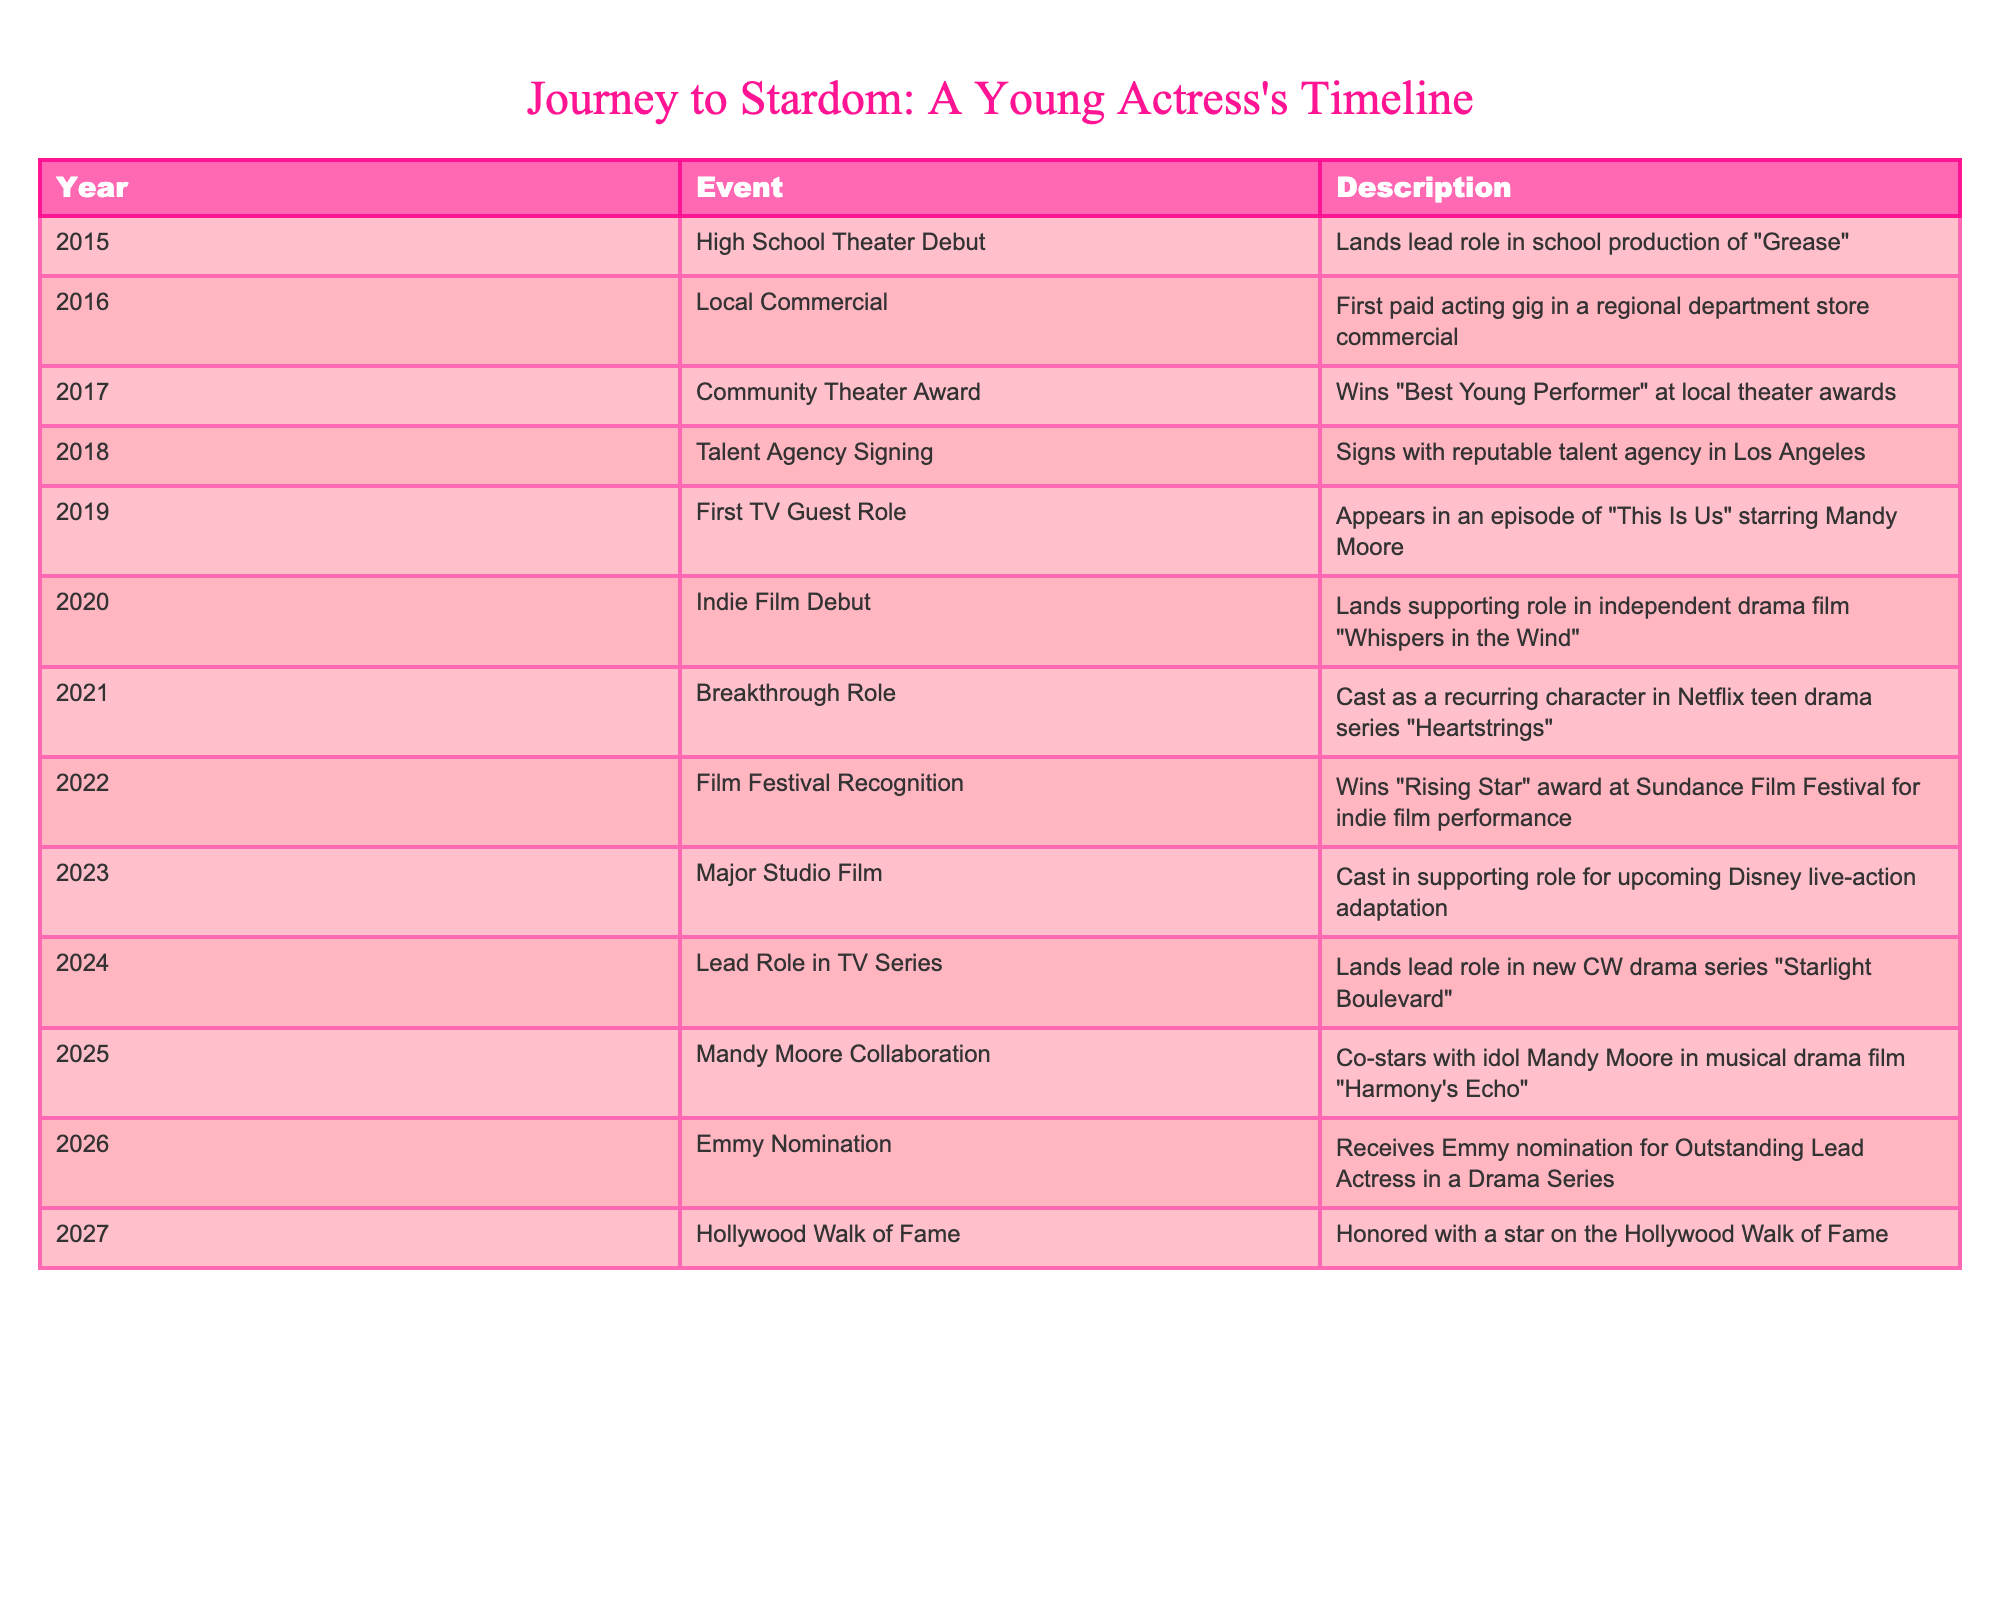What year did the actress make her high school theater debut? The table lists the year of the high school theater debut as 2015, which is the first row of the timeline.
Answer: 2015 Which award did the actress win in 2017? According to the table, in 2017 the actress won the "Best Young Performer" award at the local theater awards. This is explicitly stated in the event description.
Answer: Best Young Performer In which year did the actress sign with a talent agency? The table states that the actress signed with a talent agency in Los Angeles in 2018, shown in the fourth row of the table.
Answer: 2018 How many years passed between her first TV guest role and her breakthrough role? The first TV guest role occurred in 2019, and the breakthrough role was in 2021. The difference between these years is 2021 - 2019 = 2 years.
Answer: 2 years Did the actress collaborate with Mandy Moore? The table shows that in 2025, the actress co-starred with her idol Mandy Moore in the film "Harmony's Echo," confirming that she did collaborate with her.
Answer: Yes What is the total number of major events listed for the actress from 2015 to 2027? The table contains 13 rows, each representing a significant event in the actress's timeline from 2015 to 2027, indicating that there are a total of 13 major events.
Answer: 13 What was the actress's major role in 2023? In 2023, the table indicates that the actress was cast in a supporting role for an upcoming Disney live-action adaptation. This describes her major role for that year.
Answer: Supporting role in Disney live-action adaptation What is the median year for all events listed in the timeline? The years listed in order are 2015, 2016, 2017, 2018, 2019, 2020, 2021, 2022, 2023, 2024, 2025, 2026, 2027. There are 13 data points, so the median is the 7th value: 2021.
Answer: 2021 How many years were there between the indie film debut and the first significant recognition at a film festival? The indie film debut occurred in 2020, and the film festival recognition occurred in 2022. The difference is 2022 - 2020 = 2 years.
Answer: 2 years 